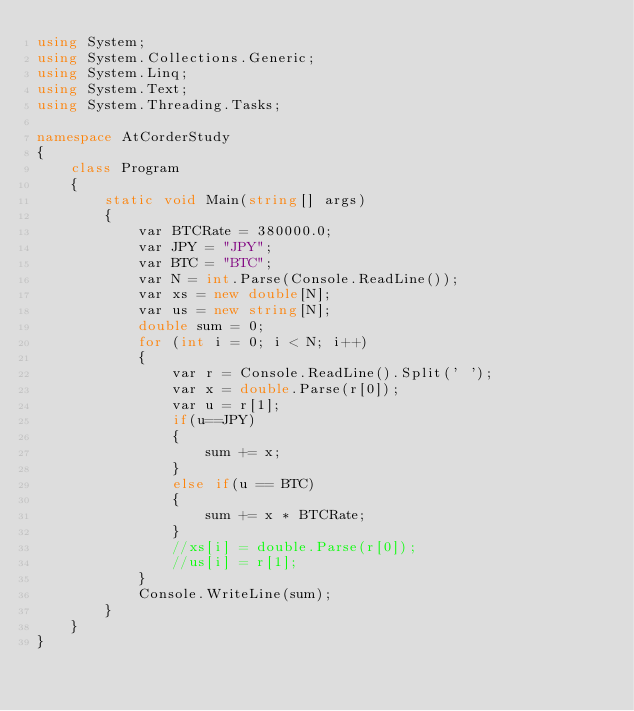Convert code to text. <code><loc_0><loc_0><loc_500><loc_500><_C#_>using System;
using System.Collections.Generic;
using System.Linq;
using System.Text;
using System.Threading.Tasks;

namespace AtCorderStudy
{
    class Program
    {
        static void Main(string[] args)
        {
            var BTCRate = 380000.0;
            var JPY = "JPY";
            var BTC = "BTC";
            var N = int.Parse(Console.ReadLine());
            var xs = new double[N];
            var us = new string[N];
            double sum = 0;
            for (int i = 0; i < N; i++)
            {
                var r = Console.ReadLine().Split(' ');
                var x = double.Parse(r[0]);
                var u = r[1];
                if(u==JPY)
                {
                    sum += x;
                }
                else if(u == BTC)
                {
                    sum += x * BTCRate;
                }
                //xs[i] = double.Parse(r[0]);
                //us[i] = r[1];
            }
            Console.WriteLine(sum);
        }
    }
}
</code> 